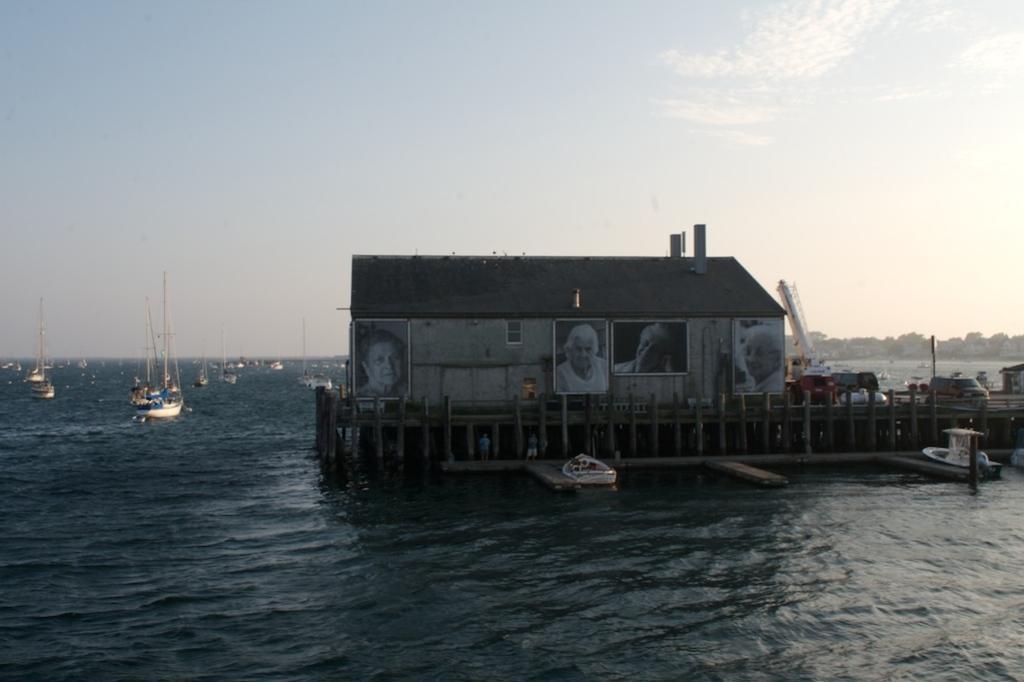Describe this image in one or two sentences. In this image we can see a house with roof, photo frames and windows built on the bridge. We can see some people standing under a bridge and two boats kept aside. On the left side we can see some boats on the water and the sky which looks cloudy. 